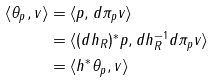Convert formula to latex. <formula><loc_0><loc_0><loc_500><loc_500>\langle \theta _ { p } , v \rangle & = \langle p , d \pi _ { p } v \rangle \\ & = \langle ( d h _ { R } ) ^ { * } p , d h ^ { - 1 } _ { R } d \pi _ { p } v \rangle \\ & = \langle h ^ { * } \theta _ { p } , v \rangle</formula> 